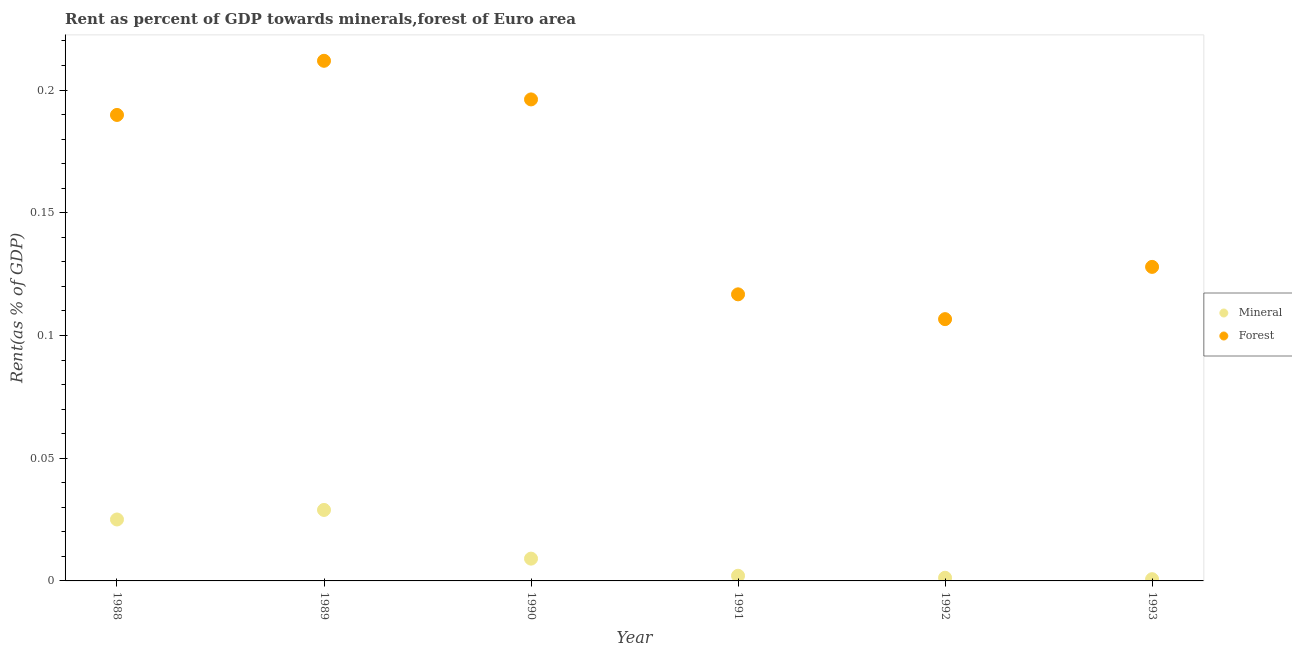How many different coloured dotlines are there?
Provide a short and direct response. 2. What is the forest rent in 1992?
Give a very brief answer. 0.11. Across all years, what is the maximum mineral rent?
Provide a succinct answer. 0.03. Across all years, what is the minimum mineral rent?
Give a very brief answer. 0. In which year was the forest rent maximum?
Your response must be concise. 1989. In which year was the mineral rent minimum?
Provide a succinct answer. 1993. What is the total mineral rent in the graph?
Provide a short and direct response. 0.07. What is the difference between the mineral rent in 1988 and that in 1989?
Offer a terse response. -0. What is the difference between the forest rent in 1993 and the mineral rent in 1991?
Make the answer very short. 0.13. What is the average forest rent per year?
Provide a succinct answer. 0.16. In the year 1988, what is the difference between the forest rent and mineral rent?
Offer a terse response. 0.16. In how many years, is the forest rent greater than 0.09 %?
Your answer should be very brief. 6. What is the ratio of the mineral rent in 1988 to that in 1993?
Provide a succinct answer. 35.45. Is the difference between the mineral rent in 1988 and 1989 greater than the difference between the forest rent in 1988 and 1989?
Keep it short and to the point. Yes. What is the difference between the highest and the second highest mineral rent?
Give a very brief answer. 0. What is the difference between the highest and the lowest mineral rent?
Make the answer very short. 0.03. Is the sum of the forest rent in 1989 and 1990 greater than the maximum mineral rent across all years?
Your response must be concise. Yes. Does the mineral rent monotonically increase over the years?
Ensure brevity in your answer.  No. How many dotlines are there?
Keep it short and to the point. 2. How many years are there in the graph?
Keep it short and to the point. 6. Are the values on the major ticks of Y-axis written in scientific E-notation?
Offer a very short reply. No. Where does the legend appear in the graph?
Your answer should be very brief. Center right. How many legend labels are there?
Provide a short and direct response. 2. What is the title of the graph?
Keep it short and to the point. Rent as percent of GDP towards minerals,forest of Euro area. Does "Nitrous oxide emissions" appear as one of the legend labels in the graph?
Offer a very short reply. No. What is the label or title of the X-axis?
Give a very brief answer. Year. What is the label or title of the Y-axis?
Ensure brevity in your answer.  Rent(as % of GDP). What is the Rent(as % of GDP) in Mineral in 1988?
Keep it short and to the point. 0.03. What is the Rent(as % of GDP) of Forest in 1988?
Ensure brevity in your answer.  0.19. What is the Rent(as % of GDP) of Mineral in 1989?
Give a very brief answer. 0.03. What is the Rent(as % of GDP) in Forest in 1989?
Your answer should be very brief. 0.21. What is the Rent(as % of GDP) in Mineral in 1990?
Offer a very short reply. 0.01. What is the Rent(as % of GDP) of Forest in 1990?
Ensure brevity in your answer.  0.2. What is the Rent(as % of GDP) of Mineral in 1991?
Your response must be concise. 0. What is the Rent(as % of GDP) in Forest in 1991?
Your answer should be very brief. 0.12. What is the Rent(as % of GDP) in Mineral in 1992?
Keep it short and to the point. 0. What is the Rent(as % of GDP) of Forest in 1992?
Ensure brevity in your answer.  0.11. What is the Rent(as % of GDP) of Mineral in 1993?
Offer a very short reply. 0. What is the Rent(as % of GDP) of Forest in 1993?
Provide a short and direct response. 0.13. Across all years, what is the maximum Rent(as % of GDP) of Mineral?
Make the answer very short. 0.03. Across all years, what is the maximum Rent(as % of GDP) in Forest?
Make the answer very short. 0.21. Across all years, what is the minimum Rent(as % of GDP) of Mineral?
Provide a succinct answer. 0. Across all years, what is the minimum Rent(as % of GDP) in Forest?
Give a very brief answer. 0.11. What is the total Rent(as % of GDP) of Mineral in the graph?
Make the answer very short. 0.07. What is the total Rent(as % of GDP) of Forest in the graph?
Give a very brief answer. 0.95. What is the difference between the Rent(as % of GDP) of Mineral in 1988 and that in 1989?
Offer a very short reply. -0. What is the difference between the Rent(as % of GDP) in Forest in 1988 and that in 1989?
Provide a succinct answer. -0.02. What is the difference between the Rent(as % of GDP) in Mineral in 1988 and that in 1990?
Your answer should be compact. 0.02. What is the difference between the Rent(as % of GDP) of Forest in 1988 and that in 1990?
Offer a terse response. -0.01. What is the difference between the Rent(as % of GDP) in Mineral in 1988 and that in 1991?
Your response must be concise. 0.02. What is the difference between the Rent(as % of GDP) of Forest in 1988 and that in 1991?
Your answer should be compact. 0.07. What is the difference between the Rent(as % of GDP) in Mineral in 1988 and that in 1992?
Offer a terse response. 0.02. What is the difference between the Rent(as % of GDP) in Forest in 1988 and that in 1992?
Ensure brevity in your answer.  0.08. What is the difference between the Rent(as % of GDP) of Mineral in 1988 and that in 1993?
Ensure brevity in your answer.  0.02. What is the difference between the Rent(as % of GDP) of Forest in 1988 and that in 1993?
Provide a short and direct response. 0.06. What is the difference between the Rent(as % of GDP) of Mineral in 1989 and that in 1990?
Provide a short and direct response. 0.02. What is the difference between the Rent(as % of GDP) of Forest in 1989 and that in 1990?
Keep it short and to the point. 0.02. What is the difference between the Rent(as % of GDP) in Mineral in 1989 and that in 1991?
Give a very brief answer. 0.03. What is the difference between the Rent(as % of GDP) in Forest in 1989 and that in 1991?
Offer a terse response. 0.1. What is the difference between the Rent(as % of GDP) in Mineral in 1989 and that in 1992?
Offer a terse response. 0.03. What is the difference between the Rent(as % of GDP) of Forest in 1989 and that in 1992?
Provide a short and direct response. 0.11. What is the difference between the Rent(as % of GDP) in Mineral in 1989 and that in 1993?
Give a very brief answer. 0.03. What is the difference between the Rent(as % of GDP) of Forest in 1989 and that in 1993?
Your response must be concise. 0.08. What is the difference between the Rent(as % of GDP) of Mineral in 1990 and that in 1991?
Give a very brief answer. 0.01. What is the difference between the Rent(as % of GDP) of Forest in 1990 and that in 1991?
Keep it short and to the point. 0.08. What is the difference between the Rent(as % of GDP) in Mineral in 1990 and that in 1992?
Provide a succinct answer. 0.01. What is the difference between the Rent(as % of GDP) of Forest in 1990 and that in 1992?
Provide a succinct answer. 0.09. What is the difference between the Rent(as % of GDP) in Mineral in 1990 and that in 1993?
Provide a short and direct response. 0.01. What is the difference between the Rent(as % of GDP) of Forest in 1990 and that in 1993?
Provide a short and direct response. 0.07. What is the difference between the Rent(as % of GDP) of Mineral in 1991 and that in 1992?
Make the answer very short. 0. What is the difference between the Rent(as % of GDP) in Forest in 1991 and that in 1992?
Offer a terse response. 0.01. What is the difference between the Rent(as % of GDP) of Mineral in 1991 and that in 1993?
Provide a short and direct response. 0. What is the difference between the Rent(as % of GDP) in Forest in 1991 and that in 1993?
Your answer should be very brief. -0.01. What is the difference between the Rent(as % of GDP) of Mineral in 1992 and that in 1993?
Give a very brief answer. 0. What is the difference between the Rent(as % of GDP) in Forest in 1992 and that in 1993?
Your answer should be very brief. -0.02. What is the difference between the Rent(as % of GDP) in Mineral in 1988 and the Rent(as % of GDP) in Forest in 1989?
Provide a succinct answer. -0.19. What is the difference between the Rent(as % of GDP) in Mineral in 1988 and the Rent(as % of GDP) in Forest in 1990?
Make the answer very short. -0.17. What is the difference between the Rent(as % of GDP) of Mineral in 1988 and the Rent(as % of GDP) of Forest in 1991?
Offer a terse response. -0.09. What is the difference between the Rent(as % of GDP) of Mineral in 1988 and the Rent(as % of GDP) of Forest in 1992?
Give a very brief answer. -0.08. What is the difference between the Rent(as % of GDP) of Mineral in 1988 and the Rent(as % of GDP) of Forest in 1993?
Offer a very short reply. -0.1. What is the difference between the Rent(as % of GDP) of Mineral in 1989 and the Rent(as % of GDP) of Forest in 1990?
Make the answer very short. -0.17. What is the difference between the Rent(as % of GDP) of Mineral in 1989 and the Rent(as % of GDP) of Forest in 1991?
Provide a succinct answer. -0.09. What is the difference between the Rent(as % of GDP) of Mineral in 1989 and the Rent(as % of GDP) of Forest in 1992?
Your response must be concise. -0.08. What is the difference between the Rent(as % of GDP) of Mineral in 1989 and the Rent(as % of GDP) of Forest in 1993?
Your answer should be compact. -0.1. What is the difference between the Rent(as % of GDP) of Mineral in 1990 and the Rent(as % of GDP) of Forest in 1991?
Provide a short and direct response. -0.11. What is the difference between the Rent(as % of GDP) of Mineral in 1990 and the Rent(as % of GDP) of Forest in 1992?
Provide a short and direct response. -0.1. What is the difference between the Rent(as % of GDP) in Mineral in 1990 and the Rent(as % of GDP) in Forest in 1993?
Ensure brevity in your answer.  -0.12. What is the difference between the Rent(as % of GDP) of Mineral in 1991 and the Rent(as % of GDP) of Forest in 1992?
Provide a short and direct response. -0.1. What is the difference between the Rent(as % of GDP) in Mineral in 1991 and the Rent(as % of GDP) in Forest in 1993?
Keep it short and to the point. -0.13. What is the difference between the Rent(as % of GDP) in Mineral in 1992 and the Rent(as % of GDP) in Forest in 1993?
Keep it short and to the point. -0.13. What is the average Rent(as % of GDP) of Mineral per year?
Your answer should be compact. 0.01. What is the average Rent(as % of GDP) in Forest per year?
Your answer should be compact. 0.16. In the year 1988, what is the difference between the Rent(as % of GDP) in Mineral and Rent(as % of GDP) in Forest?
Your response must be concise. -0.16. In the year 1989, what is the difference between the Rent(as % of GDP) in Mineral and Rent(as % of GDP) in Forest?
Your answer should be very brief. -0.18. In the year 1990, what is the difference between the Rent(as % of GDP) in Mineral and Rent(as % of GDP) in Forest?
Offer a very short reply. -0.19. In the year 1991, what is the difference between the Rent(as % of GDP) in Mineral and Rent(as % of GDP) in Forest?
Offer a very short reply. -0.11. In the year 1992, what is the difference between the Rent(as % of GDP) in Mineral and Rent(as % of GDP) in Forest?
Give a very brief answer. -0.11. In the year 1993, what is the difference between the Rent(as % of GDP) in Mineral and Rent(as % of GDP) in Forest?
Offer a terse response. -0.13. What is the ratio of the Rent(as % of GDP) in Mineral in 1988 to that in 1989?
Offer a terse response. 0.87. What is the ratio of the Rent(as % of GDP) of Forest in 1988 to that in 1989?
Offer a terse response. 0.9. What is the ratio of the Rent(as % of GDP) in Mineral in 1988 to that in 1990?
Provide a short and direct response. 2.76. What is the ratio of the Rent(as % of GDP) of Forest in 1988 to that in 1990?
Offer a very short reply. 0.97. What is the ratio of the Rent(as % of GDP) of Mineral in 1988 to that in 1991?
Your response must be concise. 11.89. What is the ratio of the Rent(as % of GDP) in Forest in 1988 to that in 1991?
Your response must be concise. 1.63. What is the ratio of the Rent(as % of GDP) of Mineral in 1988 to that in 1992?
Give a very brief answer. 19.52. What is the ratio of the Rent(as % of GDP) in Forest in 1988 to that in 1992?
Offer a very short reply. 1.78. What is the ratio of the Rent(as % of GDP) in Mineral in 1988 to that in 1993?
Provide a succinct answer. 35.45. What is the ratio of the Rent(as % of GDP) of Forest in 1988 to that in 1993?
Keep it short and to the point. 1.48. What is the ratio of the Rent(as % of GDP) of Mineral in 1989 to that in 1990?
Make the answer very short. 3.18. What is the ratio of the Rent(as % of GDP) in Forest in 1989 to that in 1990?
Your response must be concise. 1.08. What is the ratio of the Rent(as % of GDP) in Mineral in 1989 to that in 1991?
Give a very brief answer. 13.73. What is the ratio of the Rent(as % of GDP) of Forest in 1989 to that in 1991?
Offer a terse response. 1.81. What is the ratio of the Rent(as % of GDP) of Mineral in 1989 to that in 1992?
Offer a terse response. 22.55. What is the ratio of the Rent(as % of GDP) of Forest in 1989 to that in 1992?
Your answer should be very brief. 1.99. What is the ratio of the Rent(as % of GDP) in Mineral in 1989 to that in 1993?
Make the answer very short. 40.96. What is the ratio of the Rent(as % of GDP) of Forest in 1989 to that in 1993?
Your answer should be very brief. 1.66. What is the ratio of the Rent(as % of GDP) in Mineral in 1990 to that in 1991?
Your response must be concise. 4.31. What is the ratio of the Rent(as % of GDP) in Forest in 1990 to that in 1991?
Your answer should be very brief. 1.68. What is the ratio of the Rent(as % of GDP) in Mineral in 1990 to that in 1992?
Make the answer very short. 7.08. What is the ratio of the Rent(as % of GDP) of Forest in 1990 to that in 1992?
Offer a very short reply. 1.84. What is the ratio of the Rent(as % of GDP) of Mineral in 1990 to that in 1993?
Keep it short and to the point. 12.86. What is the ratio of the Rent(as % of GDP) in Forest in 1990 to that in 1993?
Your response must be concise. 1.53. What is the ratio of the Rent(as % of GDP) of Mineral in 1991 to that in 1992?
Your answer should be very brief. 1.64. What is the ratio of the Rent(as % of GDP) of Forest in 1991 to that in 1992?
Offer a very short reply. 1.09. What is the ratio of the Rent(as % of GDP) in Mineral in 1991 to that in 1993?
Your response must be concise. 2.98. What is the ratio of the Rent(as % of GDP) in Forest in 1991 to that in 1993?
Offer a very short reply. 0.91. What is the ratio of the Rent(as % of GDP) of Mineral in 1992 to that in 1993?
Offer a very short reply. 1.82. What is the ratio of the Rent(as % of GDP) in Forest in 1992 to that in 1993?
Give a very brief answer. 0.83. What is the difference between the highest and the second highest Rent(as % of GDP) of Mineral?
Give a very brief answer. 0. What is the difference between the highest and the second highest Rent(as % of GDP) in Forest?
Keep it short and to the point. 0.02. What is the difference between the highest and the lowest Rent(as % of GDP) of Mineral?
Give a very brief answer. 0.03. What is the difference between the highest and the lowest Rent(as % of GDP) of Forest?
Ensure brevity in your answer.  0.11. 